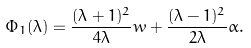Convert formula to latex. <formula><loc_0><loc_0><loc_500><loc_500>\Phi _ { 1 } ( \lambda ) = \frac { ( \lambda + 1 ) ^ { 2 } } { 4 \lambda } w + \frac { ( \lambda - 1 ) ^ { 2 } } { 2 \lambda } \alpha .</formula> 